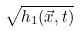Convert formula to latex. <formula><loc_0><loc_0><loc_500><loc_500>\sqrt { h _ { 1 } ( \vec { x } , t ) }</formula> 